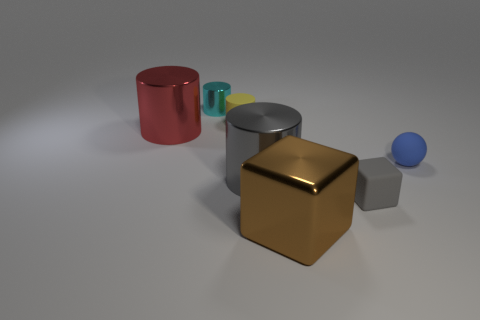Subtract all big red cylinders. How many cylinders are left? 3 Add 2 large blue cylinders. How many objects exist? 9 Subtract all brown cubes. How many cubes are left? 1 Subtract 1 blocks. How many blocks are left? 1 Subtract all yellow cubes. Subtract all yellow cylinders. How many cubes are left? 2 Subtract all big green spheres. Subtract all brown objects. How many objects are left? 6 Add 4 yellow objects. How many yellow objects are left? 5 Add 4 large red things. How many large red things exist? 5 Subtract 0 brown cylinders. How many objects are left? 7 Subtract all balls. How many objects are left? 6 